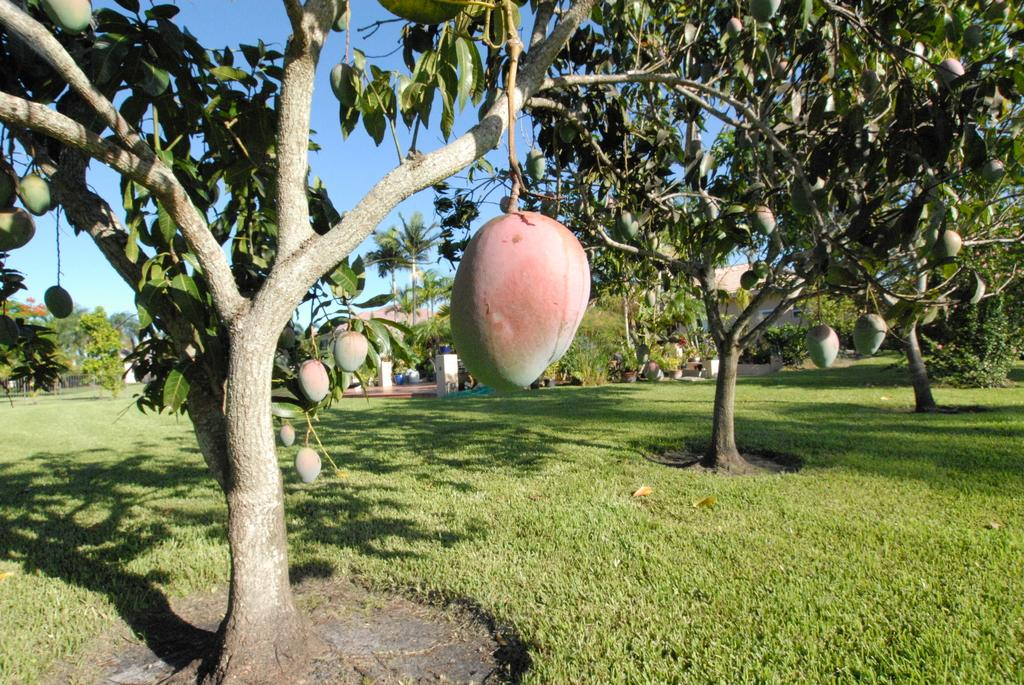What type of fruit can be seen on the trees in the image? There are trees with mangoes in the image. Can you describe the condition of the mangoes on the ground? There are mangoes on the ground in the image. What type of structures are visible in the image? There are buildings in the image. What type of vegetation is present in the image? There is grass in the image. What architectural elements can be seen in the image? There are pillars in the image. What else is present in the image that hasn't been mentioned yet? There are some unspecified objects in the image. What can be seen in the background of the image? There are trees and sky visible in the background of the image. What type of zinc can be seen in the image? There is no zinc present in the image. How many matches are visible in the image? There are no matches present in the image. 